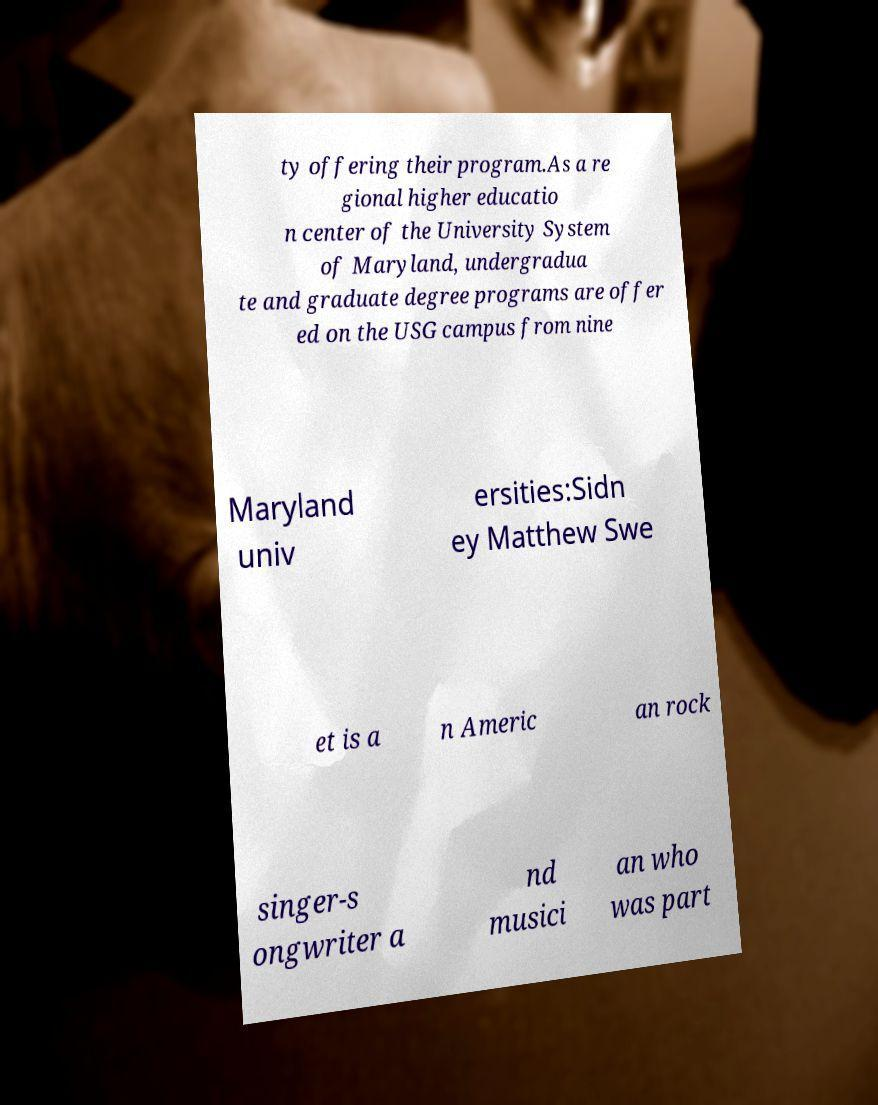Can you accurately transcribe the text from the provided image for me? ty offering their program.As a re gional higher educatio n center of the University System of Maryland, undergradua te and graduate degree programs are offer ed on the USG campus from nine Maryland univ ersities:Sidn ey Matthew Swe et is a n Americ an rock singer-s ongwriter a nd musici an who was part 